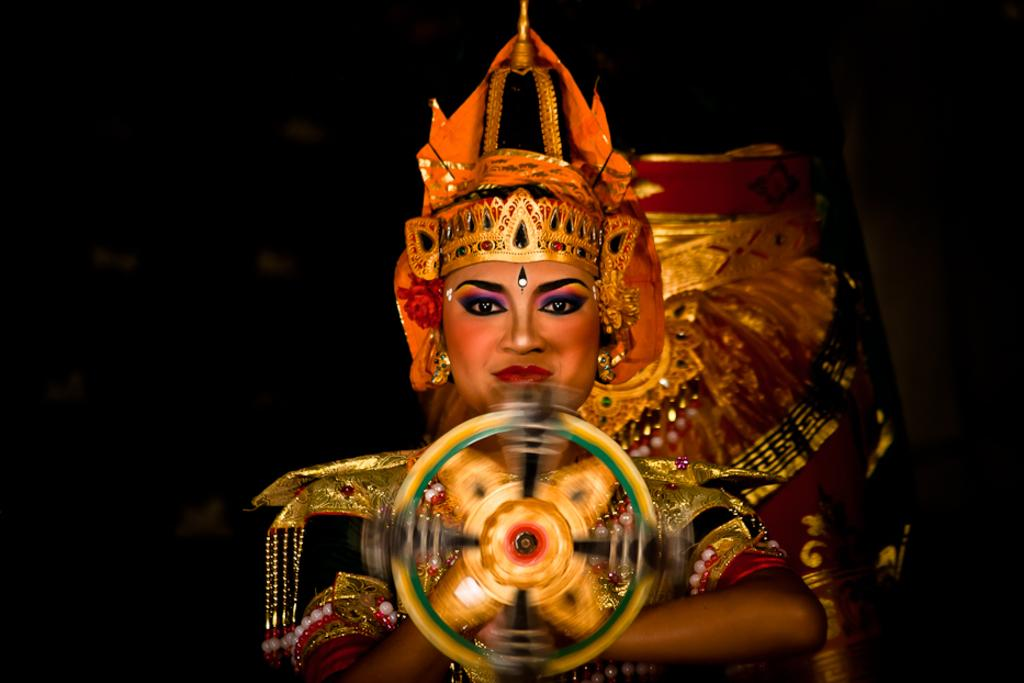Who is the main subject in the image? There is a lady in the image. Where is the lady positioned in the image? The lady is in the center of the image. What is the lady wearing in the image? The lady is wearing a costume in the image. What color is the sidewalk in the image? There is no sidewalk present in the image. Is the lady skating in the image? There is no indication of the lady skating in the image. 